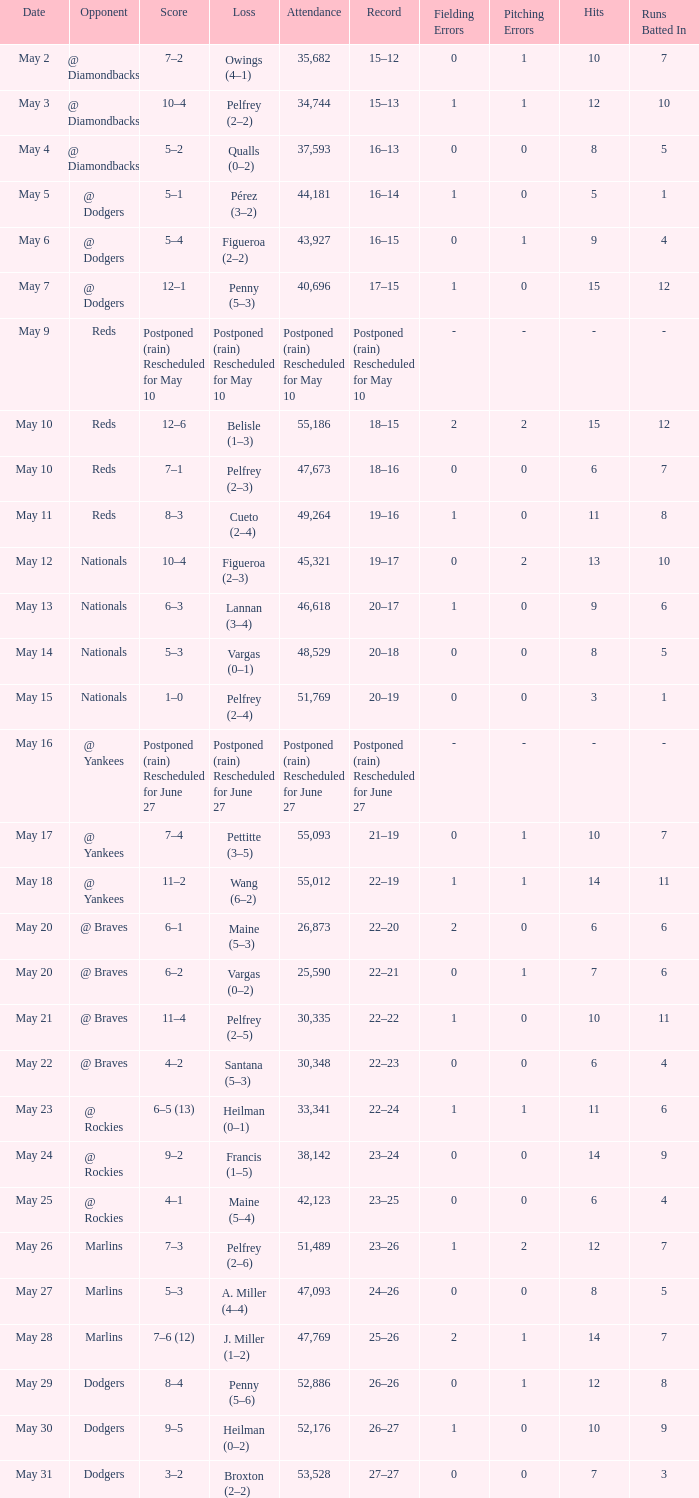Loss of postponed (rain) rescheduled for may 10 had what record? Postponed (rain) Rescheduled for May 10. 